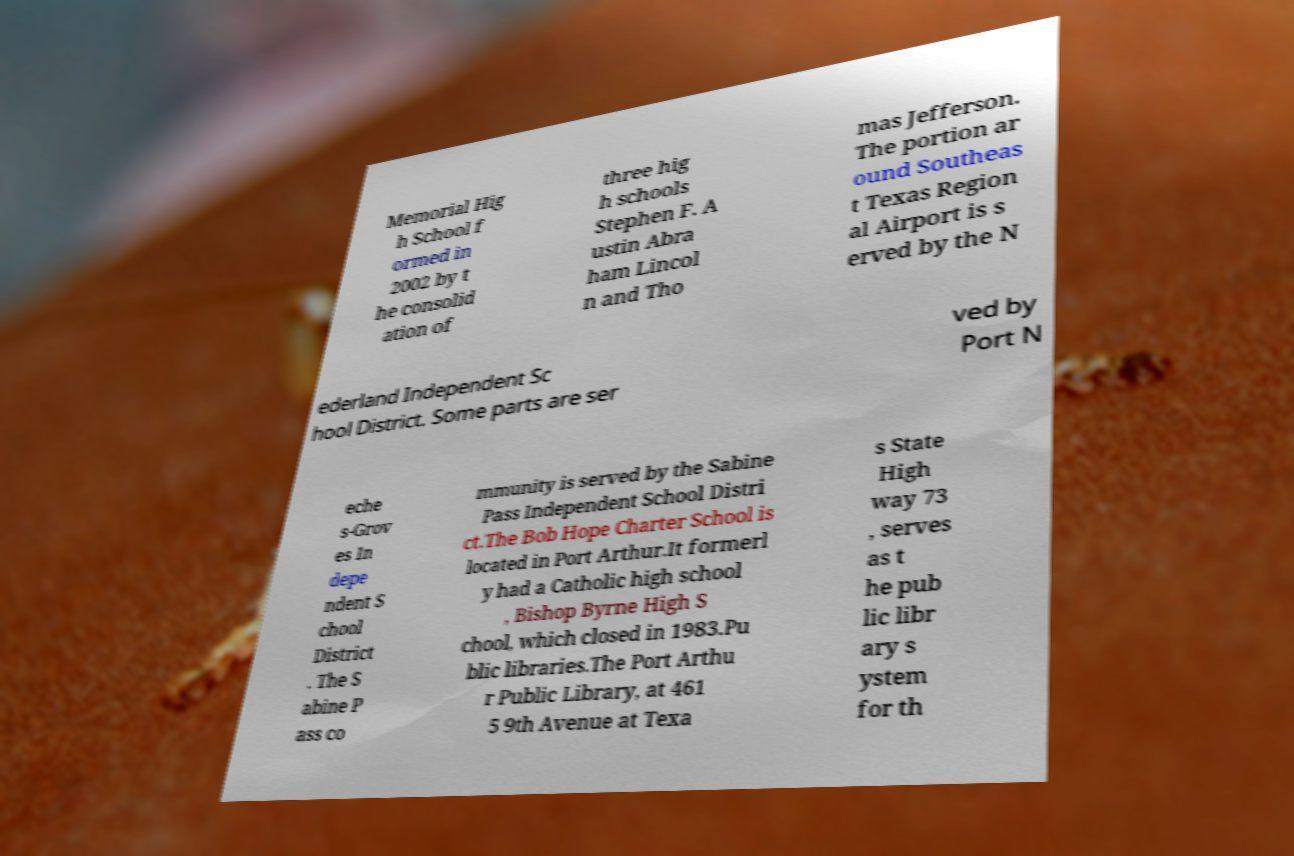Can you accurately transcribe the text from the provided image for me? Memorial Hig h School f ormed in 2002 by t he consolid ation of three hig h schools Stephen F. A ustin Abra ham Lincol n and Tho mas Jefferson. The portion ar ound Southeas t Texas Region al Airport is s erved by the N ederland Independent Sc hool District. Some parts are ser ved by Port N eche s-Grov es In depe ndent S chool District . The S abine P ass co mmunity is served by the Sabine Pass Independent School Distri ct.The Bob Hope Charter School is located in Port Arthur.It formerl y had a Catholic high school , Bishop Byrne High S chool, which closed in 1983.Pu blic libraries.The Port Arthu r Public Library, at 461 5 9th Avenue at Texa s State High way 73 , serves as t he pub lic libr ary s ystem for th 